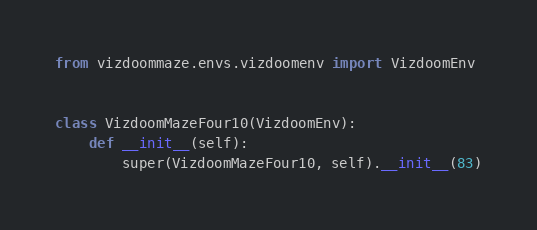Convert code to text. <code><loc_0><loc_0><loc_500><loc_500><_Python_>from vizdoommaze.envs.vizdoomenv import VizdoomEnv


class VizdoomMazeFour10(VizdoomEnv):
    def __init__(self):
        super(VizdoomMazeFour10, self).__init__(83)</code> 